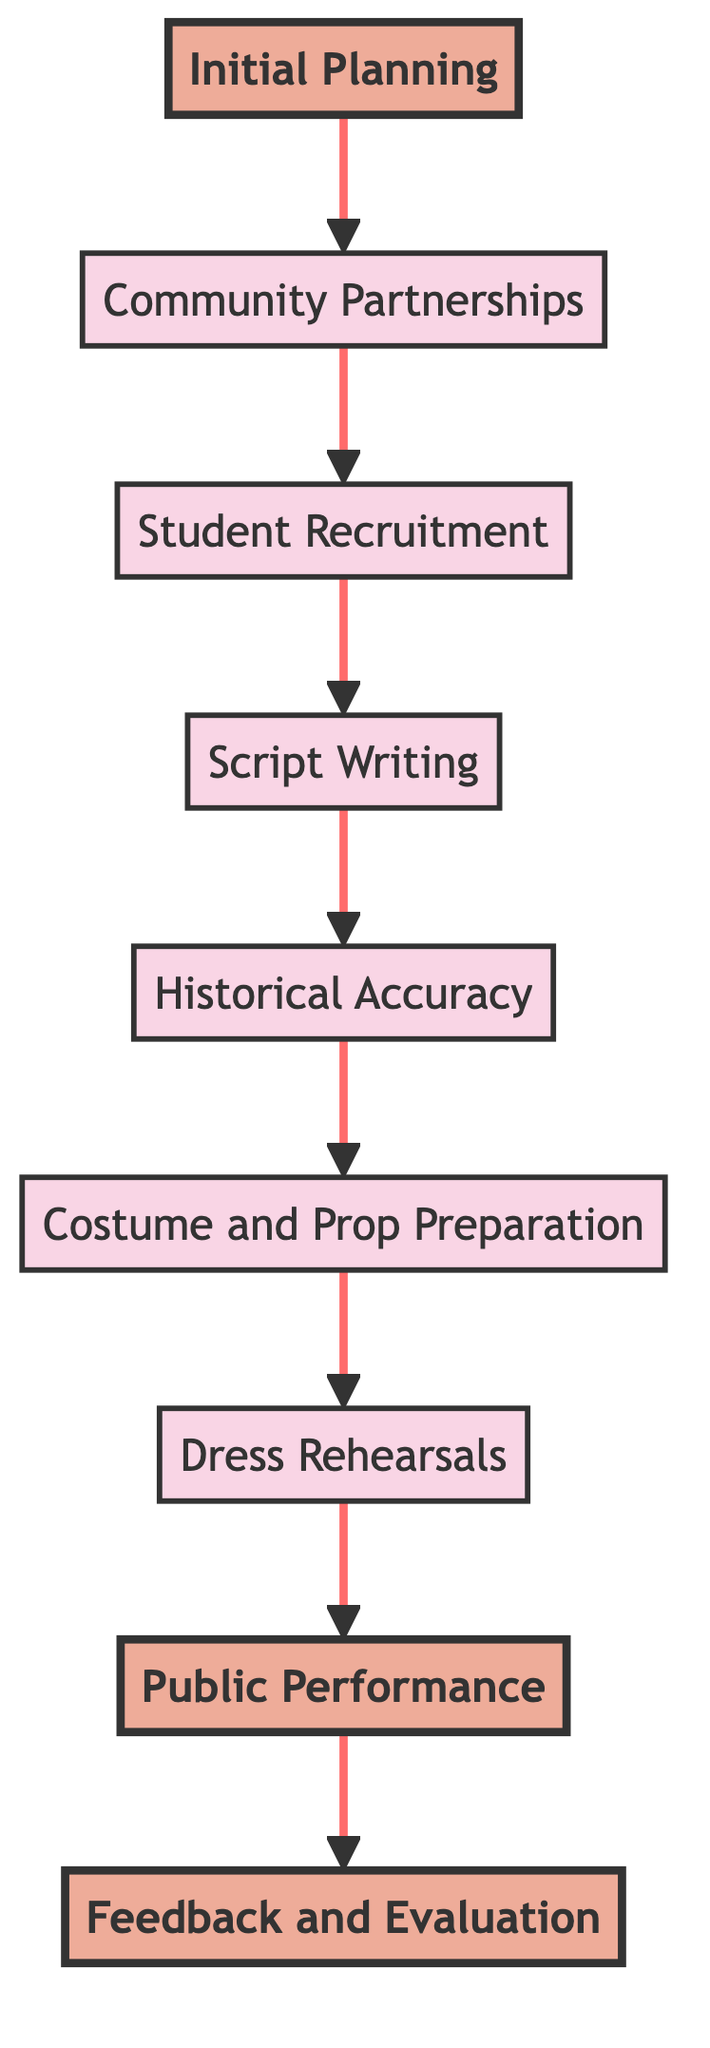What is the first step in the reenactment program? The first step, according to the diagram, is "Initial Planning". This is the node at the bottom and represents the starting point of the flow.
Answer: Initial Planning How many main nodes are present in the flowchart? The flowchart has a total of nine nodes including "Initial Planning" and "Feedback and Evaluation". This number is determined by counting each labeled box in the diagram.
Answer: Nine Which node comes directly after "Costume and Prop Preparation"? The node that follows "Costume and Prop Preparation" is "Dress Rehearsals". To arrive at this answer, you can trace the arrows that connect the nodes upward in the diagram.
Answer: Dress Rehearsals What is the last step before "Feedback and Evaluation"? The step preceding "Feedback and Evaluation" is "Public Performance". This can be identified by tracing the flow upward to see which node directs into "Feedback and Evaluation".
Answer: Public Performance Which node involves collaboration with outside organizations? "Community Partnerships" involves collaboration with local historical societies, museums, and reenactment groups. It is specifically highlighted as a collaborative effort in the diagram.
Answer: Community Partnerships What is the purpose of the "Script Writing" node? The purpose of "Script Writing" is to develop a compelling script that brings historical events and figures to life for younger readers. This is described directly in the node’s details in the diagram.
Answer: Develop a compelling script How many steps are involved between "Initial Planning" and "Public Performance"? There are six steps involved, counted as follows: Initial Planning, Community Partnerships, Student Recruitment, Script Writing, Historical Accuracy, Costume and Prop Preparation, Dress Rehearsals, and finally Public Performance.
Answer: Six Which step is emphasized in the flowchart? The steps that are emphasized in the flowchart are "Initial Planning", "Public Performance", and "Feedback and Evaluation". Each of these has a specific design treatment indicating their importance.
Answer: Initial Planning, Public Performance, Feedback and Evaluation What does "Dress Rehearsals" lead to directly? "Dress Rehearsals" leads directly to "Public Performance". Following the arrows in the diagram shows this direct flow.
Answer: Public Performance 